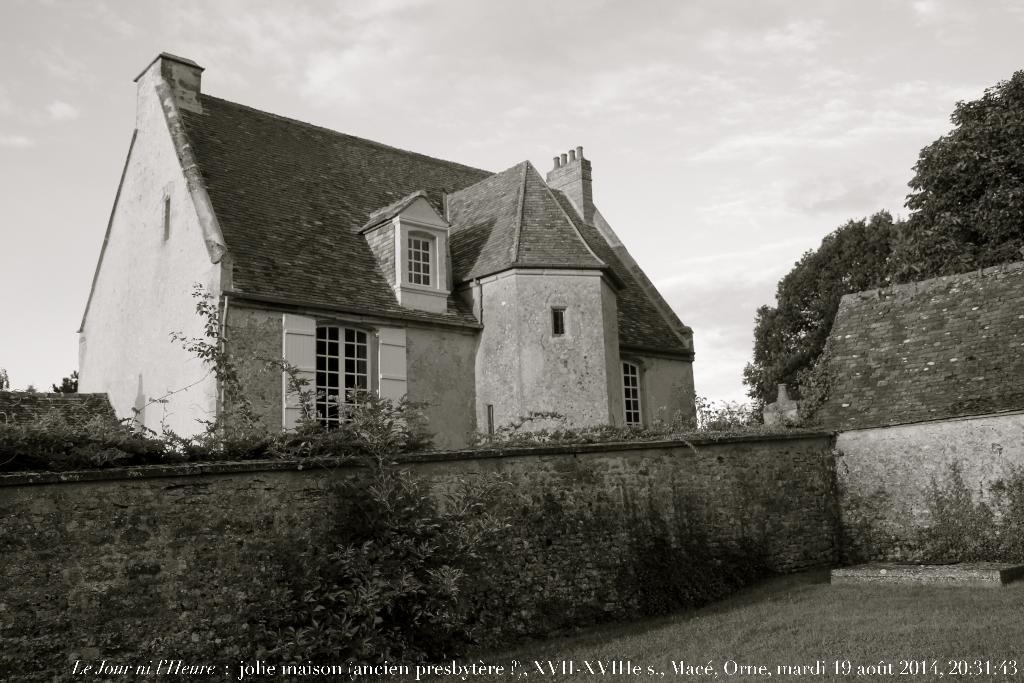What type of natural elements can be seen in the image? There are trees in the image. What type of man-made structure is present in the image? There is a building in the image. What part of the natural environment is visible in the image? The sky is visible in the image. What is the color scheme of the image? The image is in black and white. Can you tell me how many pins are holding up the trees in the image? There are no pins present in the image; the trees are standing on their own. What grade is the building in the image? The provided facts do not mention the grade or any other information about the building's classification. 